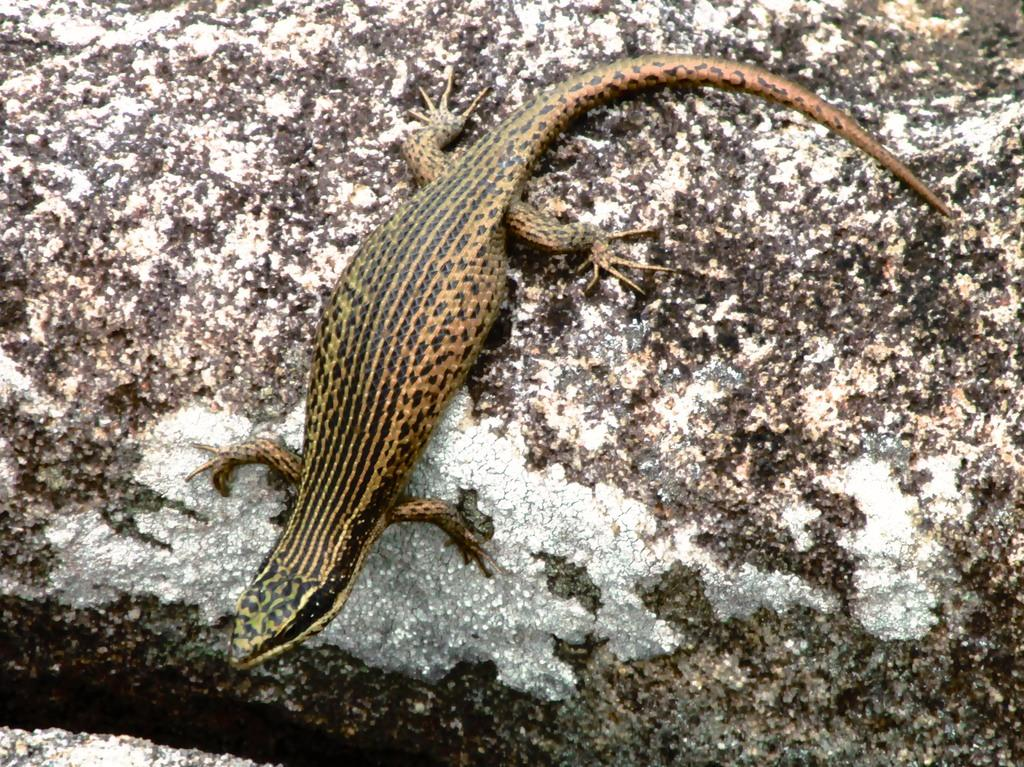Where was the image likely taken? The image appears to be taken outside. What is the main subject in the center of the image? There is a reptile in the center of the image. What is the reptile resting on? The reptile is on an object that resembles a rock. What type of waste can be seen in the image? There is no waste visible in the image. Is there a stranger interacting with the reptile in the image? There is no stranger present in the image. 